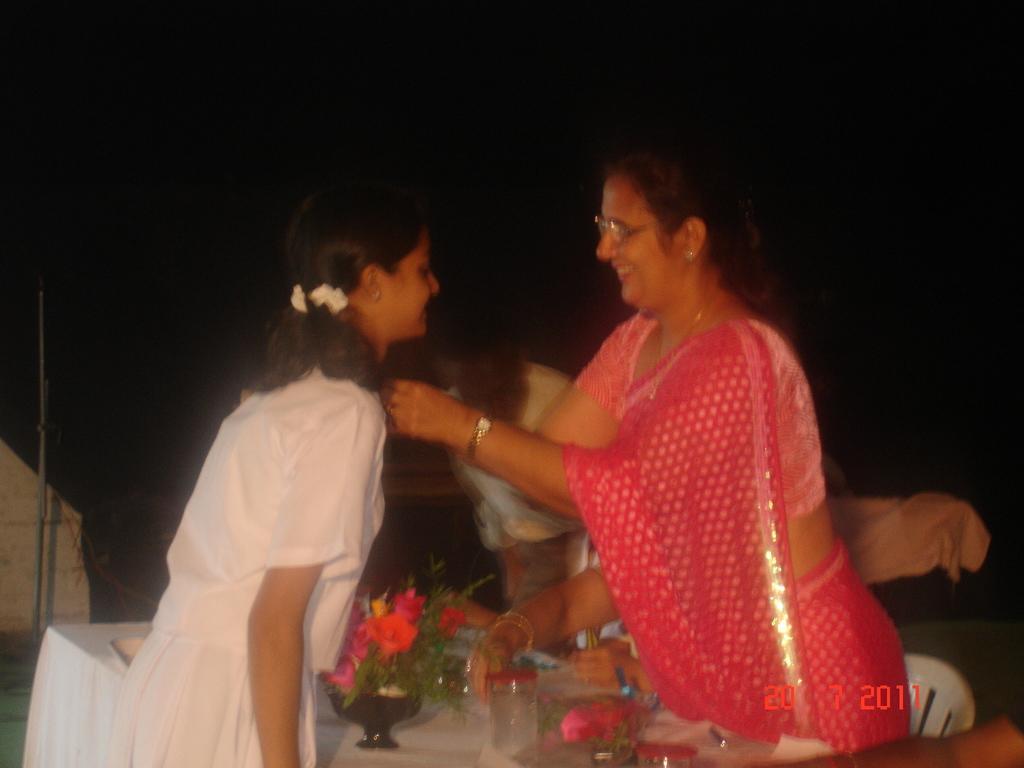Could you give a brief overview of what you see in this image? This image consists of a woman and a girl. The woman is wearing a saree. On the left, the girl is wearing a white dress. In the middle, we can see a table on which we can see a flower vase and a glass of water. On the right, we can see a chair. The background is too dark. 